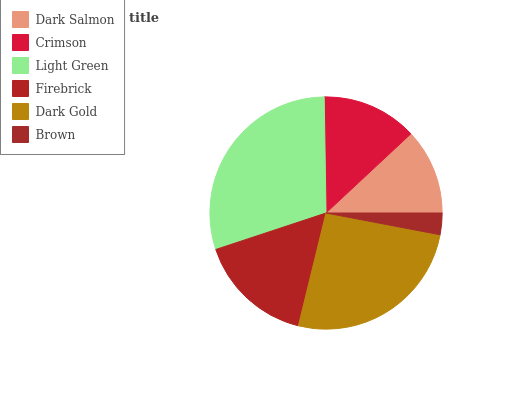Is Brown the minimum?
Answer yes or no. Yes. Is Light Green the maximum?
Answer yes or no. Yes. Is Crimson the minimum?
Answer yes or no. No. Is Crimson the maximum?
Answer yes or no. No. Is Crimson greater than Dark Salmon?
Answer yes or no. Yes. Is Dark Salmon less than Crimson?
Answer yes or no. Yes. Is Dark Salmon greater than Crimson?
Answer yes or no. No. Is Crimson less than Dark Salmon?
Answer yes or no. No. Is Firebrick the high median?
Answer yes or no. Yes. Is Crimson the low median?
Answer yes or no. Yes. Is Light Green the high median?
Answer yes or no. No. Is Dark Salmon the low median?
Answer yes or no. No. 